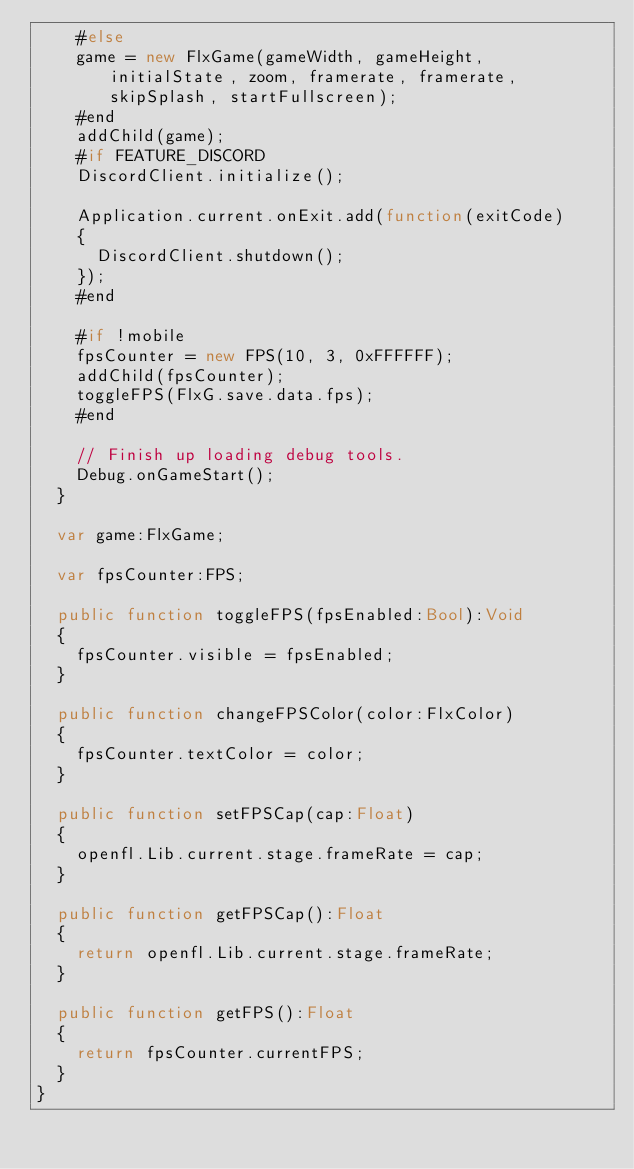<code> <loc_0><loc_0><loc_500><loc_500><_Haxe_>		#else
		game = new FlxGame(gameWidth, gameHeight, initialState, zoom, framerate, framerate, skipSplash, startFullscreen);
		#end
		addChild(game);
		#if FEATURE_DISCORD
		DiscordClient.initialize();

		Application.current.onExit.add(function(exitCode)
		{
			DiscordClient.shutdown();
		});
		#end

		#if !mobile
		fpsCounter = new FPS(10, 3, 0xFFFFFF);
		addChild(fpsCounter);
		toggleFPS(FlxG.save.data.fps);
		#end

		// Finish up loading debug tools.
		Debug.onGameStart();
	}

	var game:FlxGame;

	var fpsCounter:FPS;

	public function toggleFPS(fpsEnabled:Bool):Void
	{
		fpsCounter.visible = fpsEnabled;
	}

	public function changeFPSColor(color:FlxColor)
	{
		fpsCounter.textColor = color;
	}

	public function setFPSCap(cap:Float)
	{
		openfl.Lib.current.stage.frameRate = cap;
	}

	public function getFPSCap():Float
	{
		return openfl.Lib.current.stage.frameRate;
	}

	public function getFPS():Float
	{
		return fpsCounter.currentFPS;
	}
}
</code> 